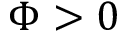<formula> <loc_0><loc_0><loc_500><loc_500>\Phi > 0</formula> 